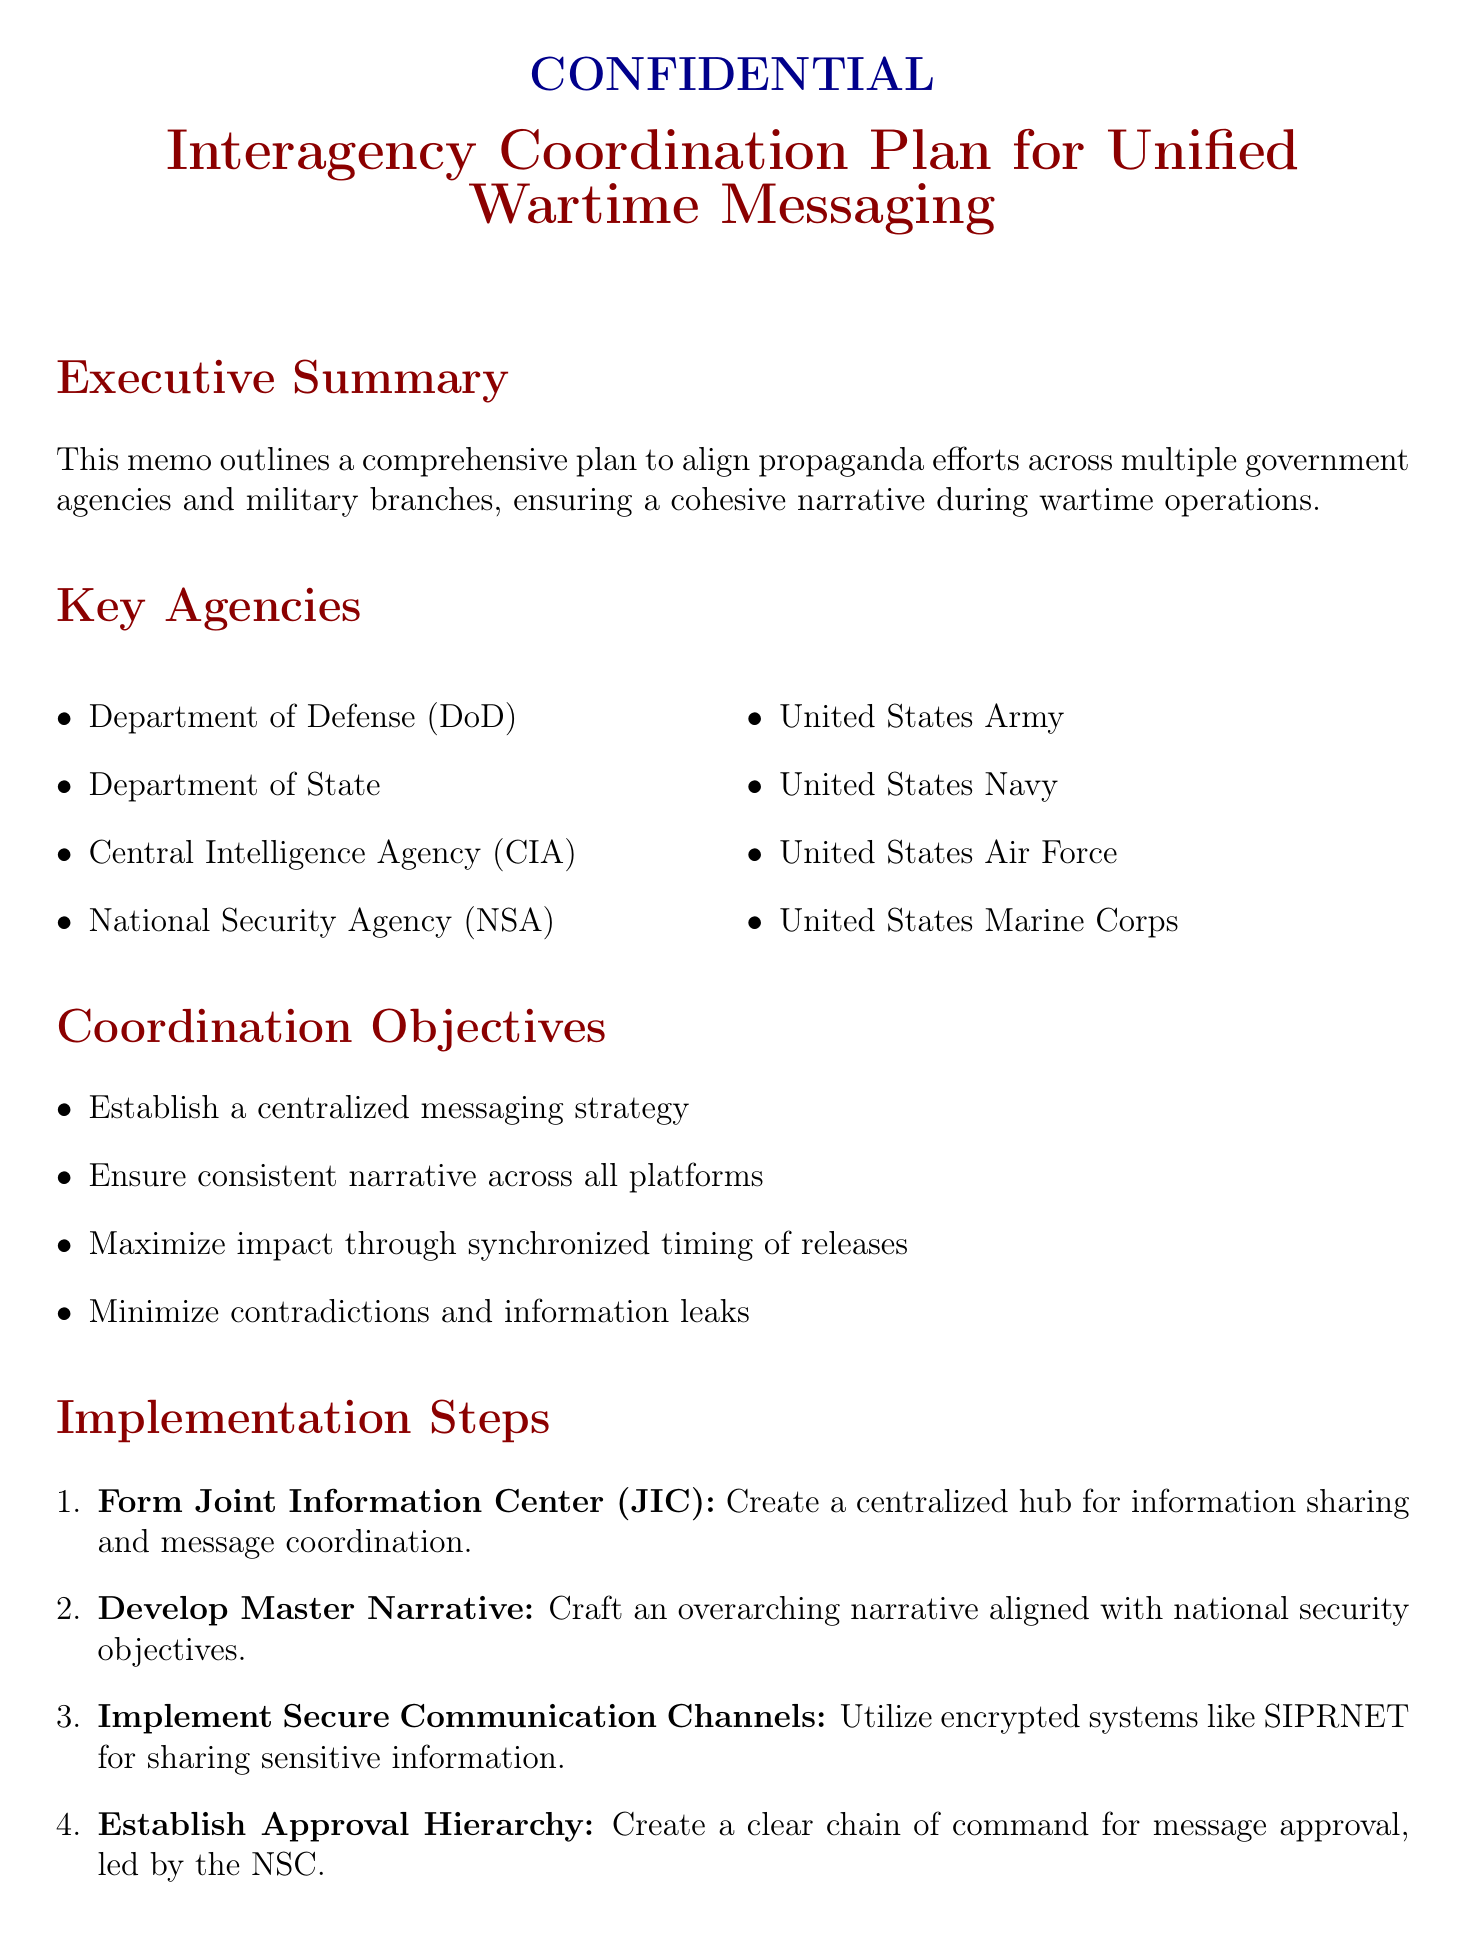What is the title of the memo? The title is the official name given to the document, which is specified in the heading.
Answer: Interagency Coordination Plan for Unified Wartime Messaging What is the purpose of the Joint Information Center (JIC)? The purpose is detailed in the implementation steps, highlighting its role in information sharing and coordination.
Answer: Centralized hub for information sharing and message coordination Who leads the approval hierarchy for messaging? The approval hierarchy detail specifies who is at the top of the chain of command, essential for clarity in leadership.
Answer: National Security Council What are the key messaging themes? This question identifies the main points emphasized in the propaganda efforts outlined in the document.
Answer: Justification for military action, Humanitarian efforts and civilian protection, Technological superiority of U.S. forces, International support and coalition efforts What are the potential challenges outlined? This question refers to risks that may hinder the effectiveness of the coordinated efforts indicated in the memo.
Answer: Information leaks, Rapidly changing battlefield situations, Conflicting agency priorities, Enemy counter-propaganda What tools will be used for monitoring and evaluation? The monitoring tools enable assessment of the effectiveness of the propaganda efforts and are listed in the document.
Answer: Media monitoring software, Social media analytics platforms, Public opinion surveys, Intelligence reports on enemy reactions What is the conclusion of the memo? The conclusion summarizes the overall goal of the coordination plan, reflecting the document's intent.
Answer: This coordination plan provides a framework for aligning propaganda efforts across government agencies and military branches Which agency is specifically mentioned for compliance considerations? This agency is noted for its specific legal compliance regarding domestic dissemination within the legal considerations section.
Answer: Smith-Mundt Act 